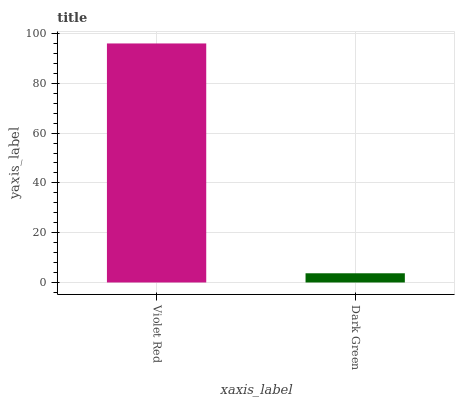Is Dark Green the minimum?
Answer yes or no. Yes. Is Violet Red the maximum?
Answer yes or no. Yes. Is Dark Green the maximum?
Answer yes or no. No. Is Violet Red greater than Dark Green?
Answer yes or no. Yes. Is Dark Green less than Violet Red?
Answer yes or no. Yes. Is Dark Green greater than Violet Red?
Answer yes or no. No. Is Violet Red less than Dark Green?
Answer yes or no. No. Is Violet Red the high median?
Answer yes or no. Yes. Is Dark Green the low median?
Answer yes or no. Yes. Is Dark Green the high median?
Answer yes or no. No. Is Violet Red the low median?
Answer yes or no. No. 